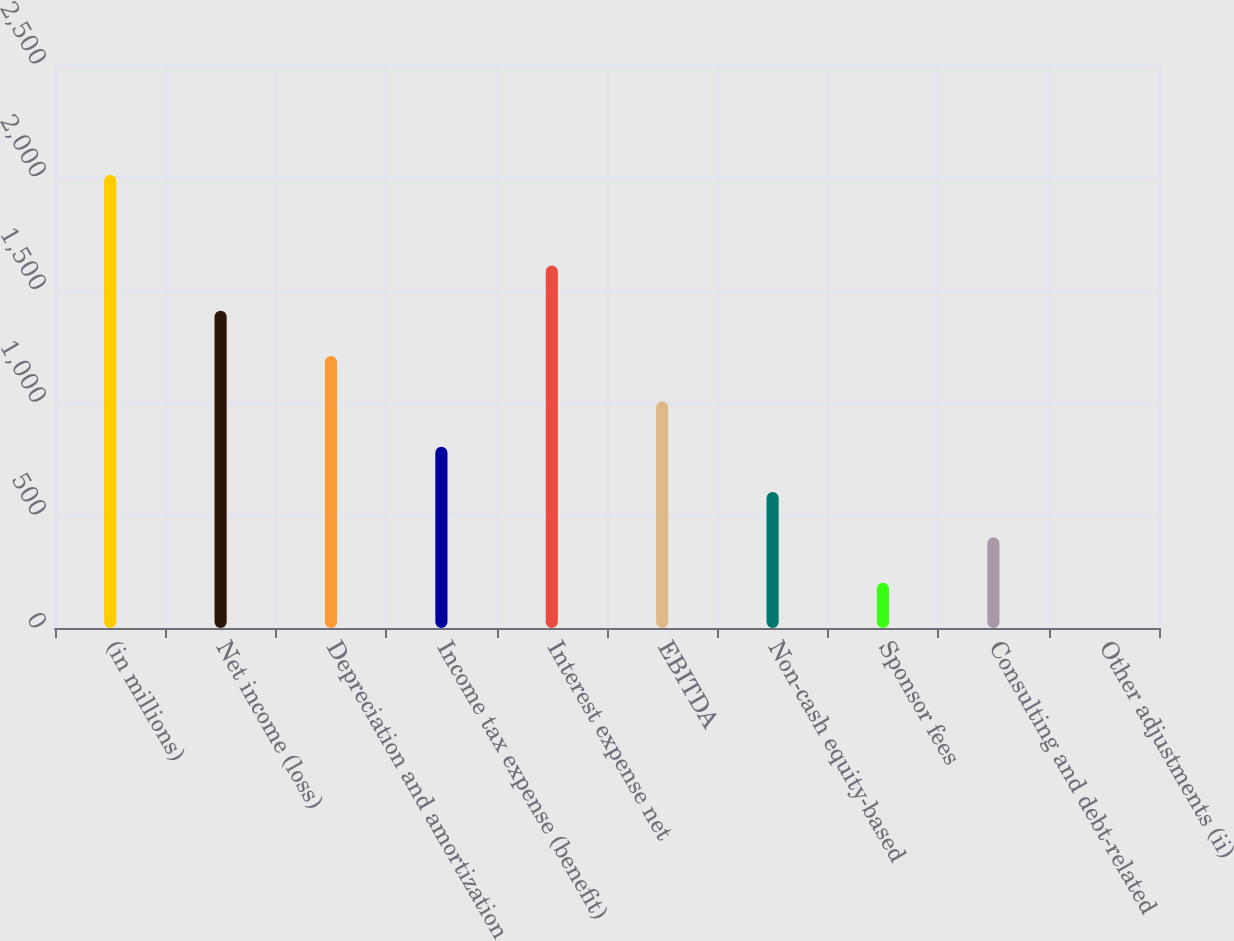<chart> <loc_0><loc_0><loc_500><loc_500><bar_chart><fcel>(in millions)<fcel>Net income (loss)<fcel>Depreciation and amortization<fcel>Income tax expense (benefit)<fcel>Interest expense net<fcel>EBITDA<fcel>Non-cash equity-based<fcel>Sponsor fees<fcel>Consulting and debt-related<fcel>Other adjustments (ii)<nl><fcel>2009<fcel>1406.33<fcel>1205.44<fcel>803.66<fcel>1607.22<fcel>1004.55<fcel>602.77<fcel>200.99<fcel>401.88<fcel>0.1<nl></chart> 